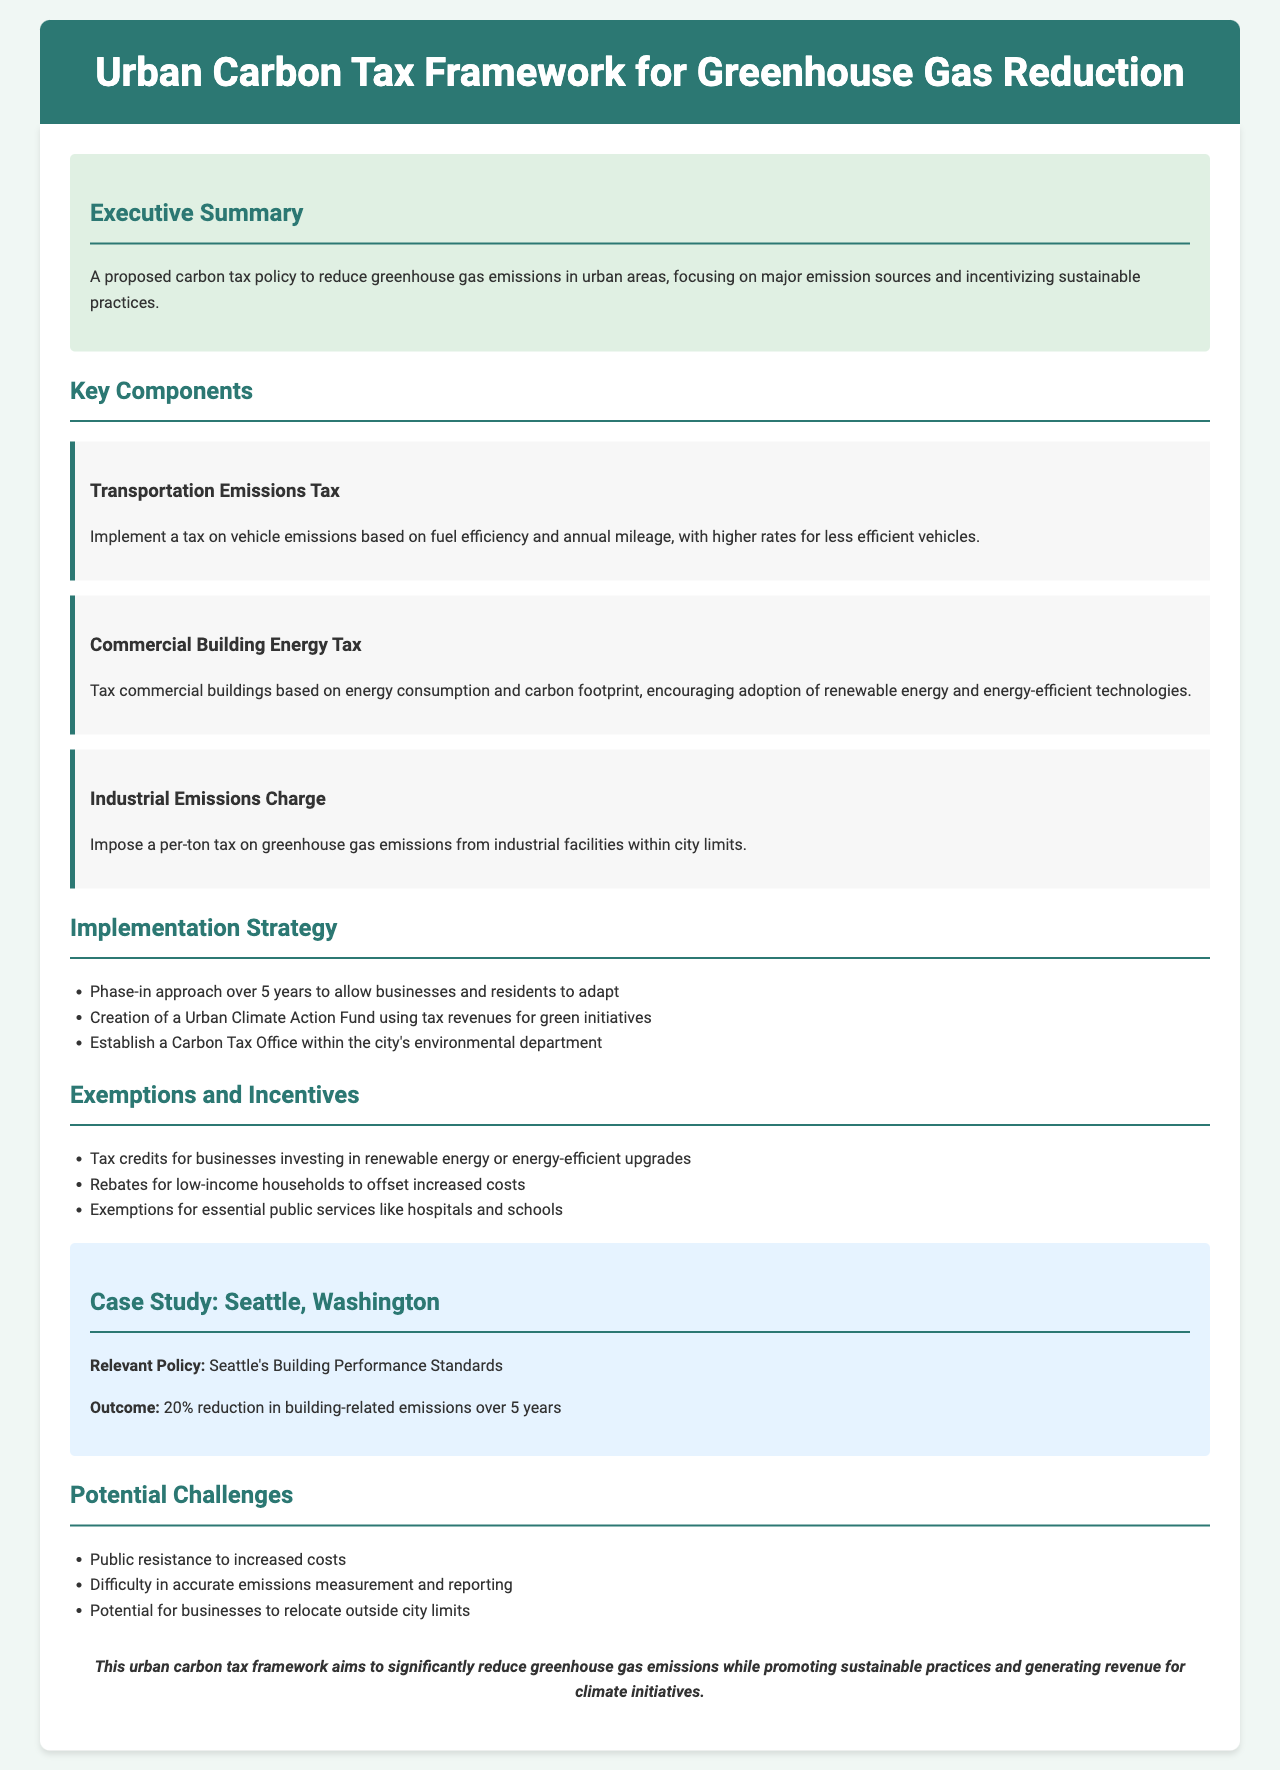What is the title of the document? The title of the document is provided in the header section, which specifies the framework for urban carbon tax initiatives.
Answer: Urban Carbon Tax Framework for Greenhouse Gas Reduction What is the main focus of the proposed policy? The proposed policy aims to target significant sources of greenhouse gas emissions in urban areas while promoting sustainable practices.
Answer: Reduce greenhouse gas emissions What is a key component of the tax policy? Reference is made to specific elements in the key components section of the document that describe taxes targeting transportation, buildings, and industries.
Answer: Transportation Emissions Tax What is one of the implementation strategies mentioned? The implementation strategy section lists specific actions for effectively introducing the carbon tax, specifically a phased approach.
Answer: Phase-in approach over 5 years What relief is provided for low-income households? The document outlines incentives aimed at easing the financial burden on certain groups affected by the tax.
Answer: Rebates for low-income households Which city is used as a case study in the document? The case study section identifies a city that has implemented relevant policies regarding building emissions reduction.
Answer: Seattle, Washington What is one potential challenge mentioned in the document? The potential challenges section highlights concerns that could arise during the implementation of the carbon tax policy.
Answer: Public resistance to increased costs What is the expected outcome from the Seattle case study? The outcome mentioned shows measurable results achieved through Seattle's policy, focusing on a percentage reduction in emissions.
Answer: 20% reduction in building-related emissions What is a purpose of the Urban Climate Action Fund? The fund's rationale is described within the implementation strategy's revenue utilization section.
Answer: For green initiatives 